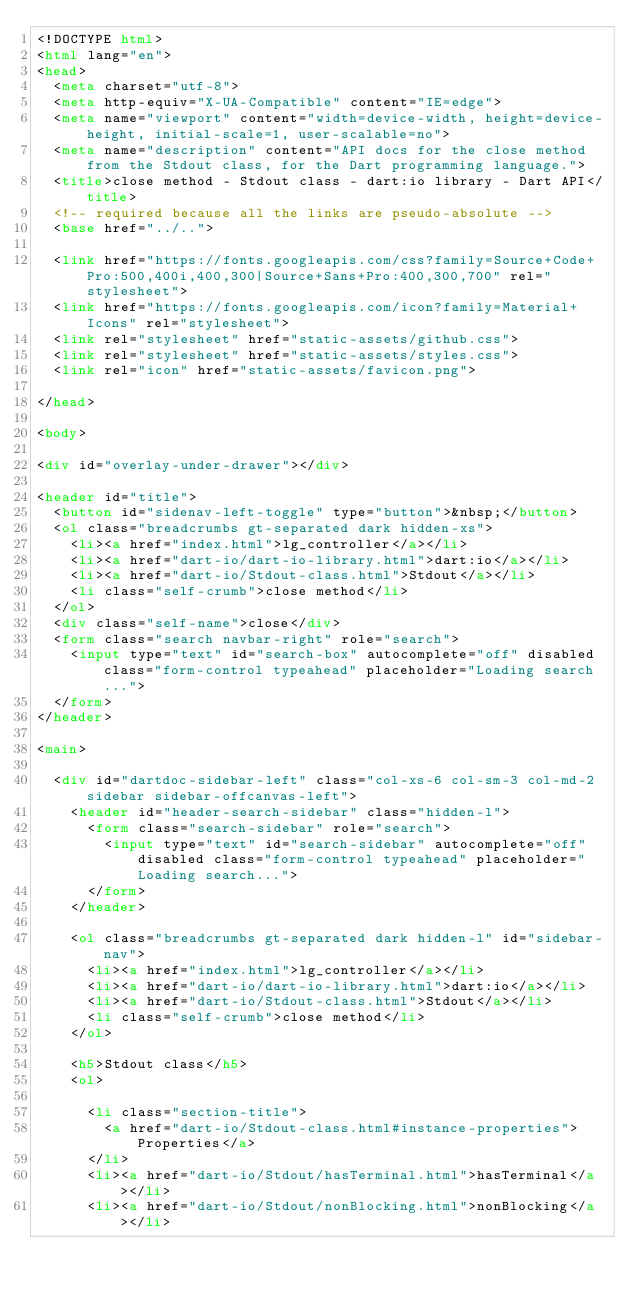Convert code to text. <code><loc_0><loc_0><loc_500><loc_500><_HTML_><!DOCTYPE html>
<html lang="en">
<head>
  <meta charset="utf-8">
  <meta http-equiv="X-UA-Compatible" content="IE=edge">
  <meta name="viewport" content="width=device-width, height=device-height, initial-scale=1, user-scalable=no">
  <meta name="description" content="API docs for the close method from the Stdout class, for the Dart programming language.">
  <title>close method - Stdout class - dart:io library - Dart API</title>
  <!-- required because all the links are pseudo-absolute -->
  <base href="../..">

  <link href="https://fonts.googleapis.com/css?family=Source+Code+Pro:500,400i,400,300|Source+Sans+Pro:400,300,700" rel="stylesheet">
  <link href="https://fonts.googleapis.com/icon?family=Material+Icons" rel="stylesheet">
  <link rel="stylesheet" href="static-assets/github.css">
  <link rel="stylesheet" href="static-assets/styles.css">
  <link rel="icon" href="static-assets/favicon.png">
  
</head>

<body>

<div id="overlay-under-drawer"></div>

<header id="title">
  <button id="sidenav-left-toggle" type="button">&nbsp;</button>
  <ol class="breadcrumbs gt-separated dark hidden-xs">
    <li><a href="index.html">lg_controller</a></li>
    <li><a href="dart-io/dart-io-library.html">dart:io</a></li>
    <li><a href="dart-io/Stdout-class.html">Stdout</a></li>
    <li class="self-crumb">close method</li>
  </ol>
  <div class="self-name">close</div>
  <form class="search navbar-right" role="search">
    <input type="text" id="search-box" autocomplete="off" disabled class="form-control typeahead" placeholder="Loading search...">
  </form>
</header>

<main>

  <div id="dartdoc-sidebar-left" class="col-xs-6 col-sm-3 col-md-2 sidebar sidebar-offcanvas-left">
    <header id="header-search-sidebar" class="hidden-l">
      <form class="search-sidebar" role="search">
        <input type="text" id="search-sidebar" autocomplete="off" disabled class="form-control typeahead" placeholder="Loading search...">
      </form>
    </header>
    
    <ol class="breadcrumbs gt-separated dark hidden-l" id="sidebar-nav">
      <li><a href="index.html">lg_controller</a></li>
      <li><a href="dart-io/dart-io-library.html">dart:io</a></li>
      <li><a href="dart-io/Stdout-class.html">Stdout</a></li>
      <li class="self-crumb">close method</li>
    </ol>
    
    <h5>Stdout class</h5>
    <ol>
    
      <li class="section-title">
        <a href="dart-io/Stdout-class.html#instance-properties">Properties</a>
      </li>
      <li><a href="dart-io/Stdout/hasTerminal.html">hasTerminal</a></li>
      <li><a href="dart-io/Stdout/nonBlocking.html">nonBlocking</a></li></code> 